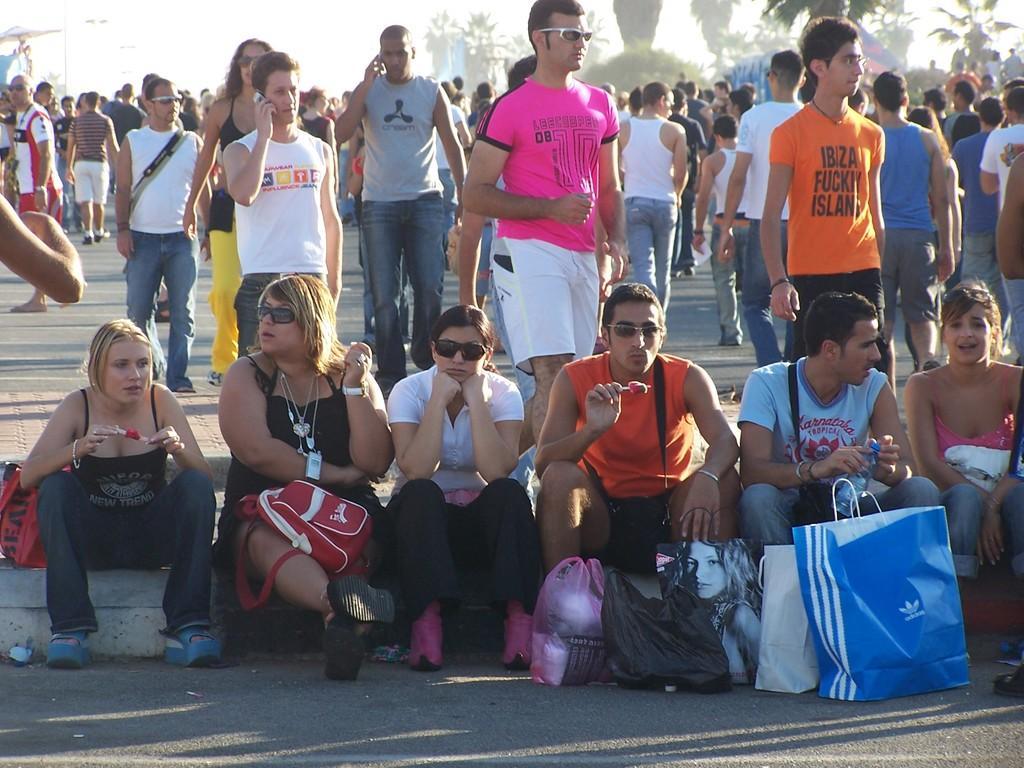In one or two sentences, can you explain what this image depicts? In this image in front there are a few people sitting on the platform. In front of them there are bags. Behind them there are a few people walking on the road. In the background of the image there are trees and sky. 